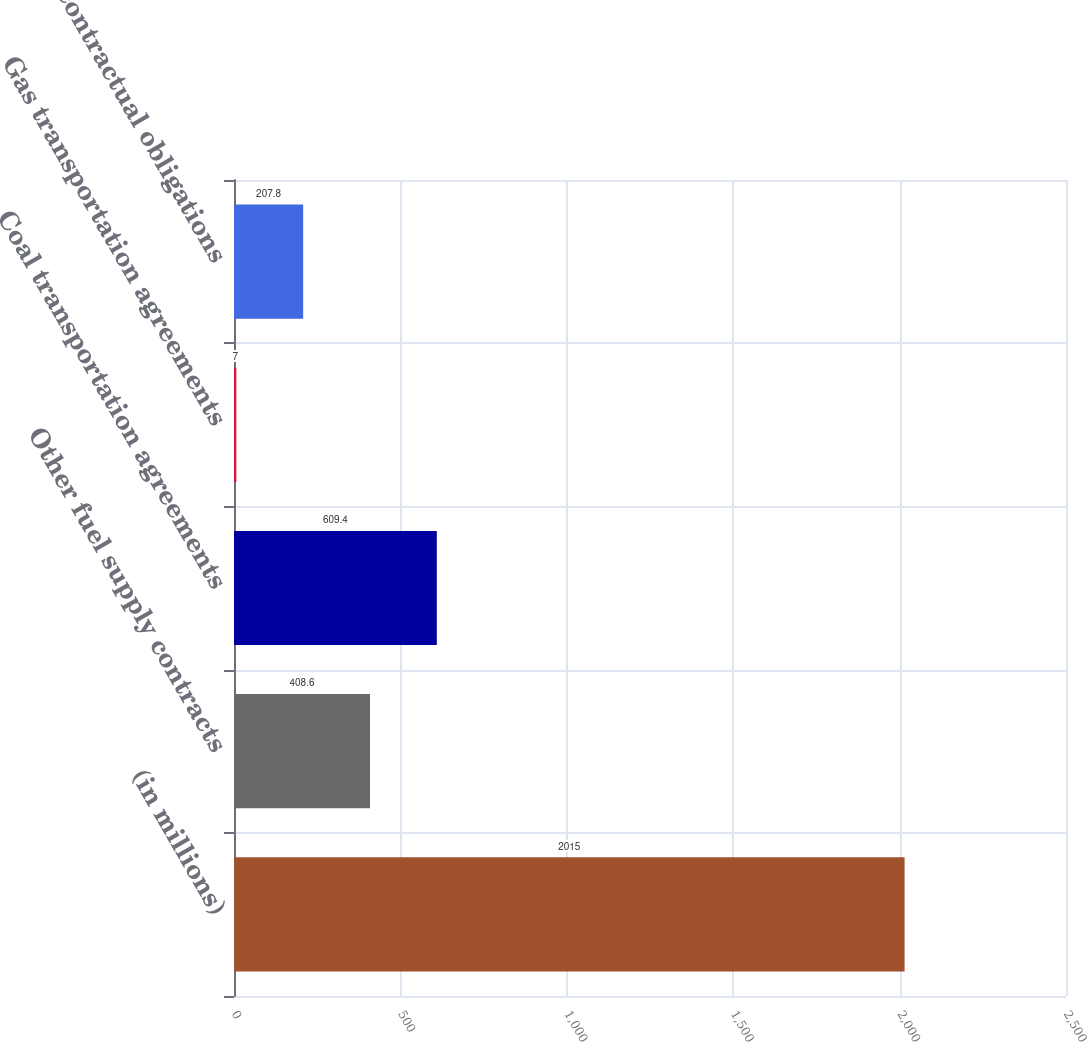Convert chart to OTSL. <chart><loc_0><loc_0><loc_500><loc_500><bar_chart><fcel>(in millions)<fcel>Other fuel supply contracts<fcel>Coal transportation agreements<fcel>Gas transportation agreements<fcel>Other contractual obligations<nl><fcel>2015<fcel>408.6<fcel>609.4<fcel>7<fcel>207.8<nl></chart> 